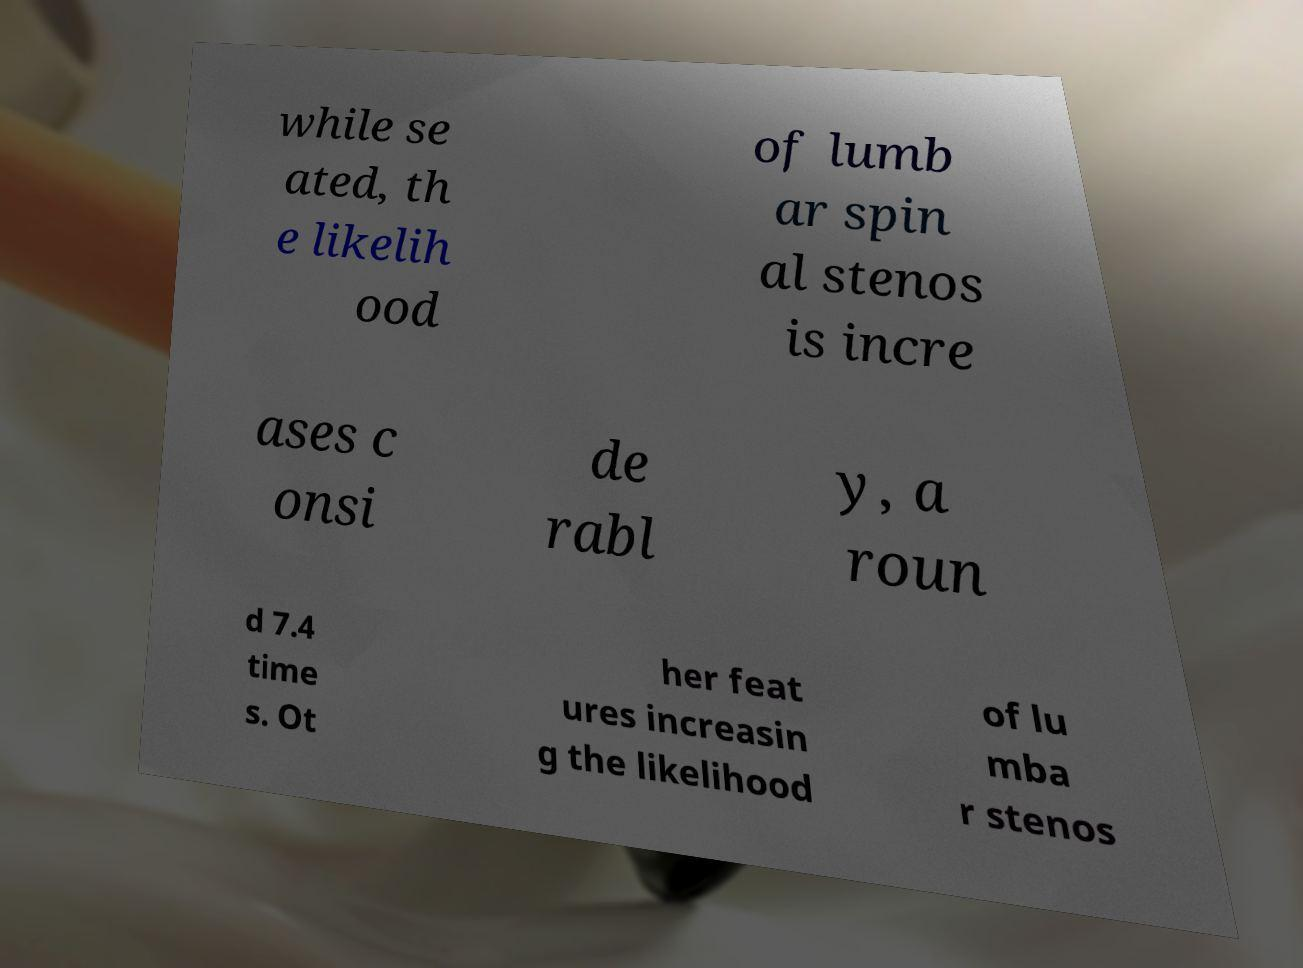Can you read and provide the text displayed in the image?This photo seems to have some interesting text. Can you extract and type it out for me? while se ated, th e likelih ood of lumb ar spin al stenos is incre ases c onsi de rabl y, a roun d 7.4 time s. Ot her feat ures increasin g the likelihood of lu mba r stenos 